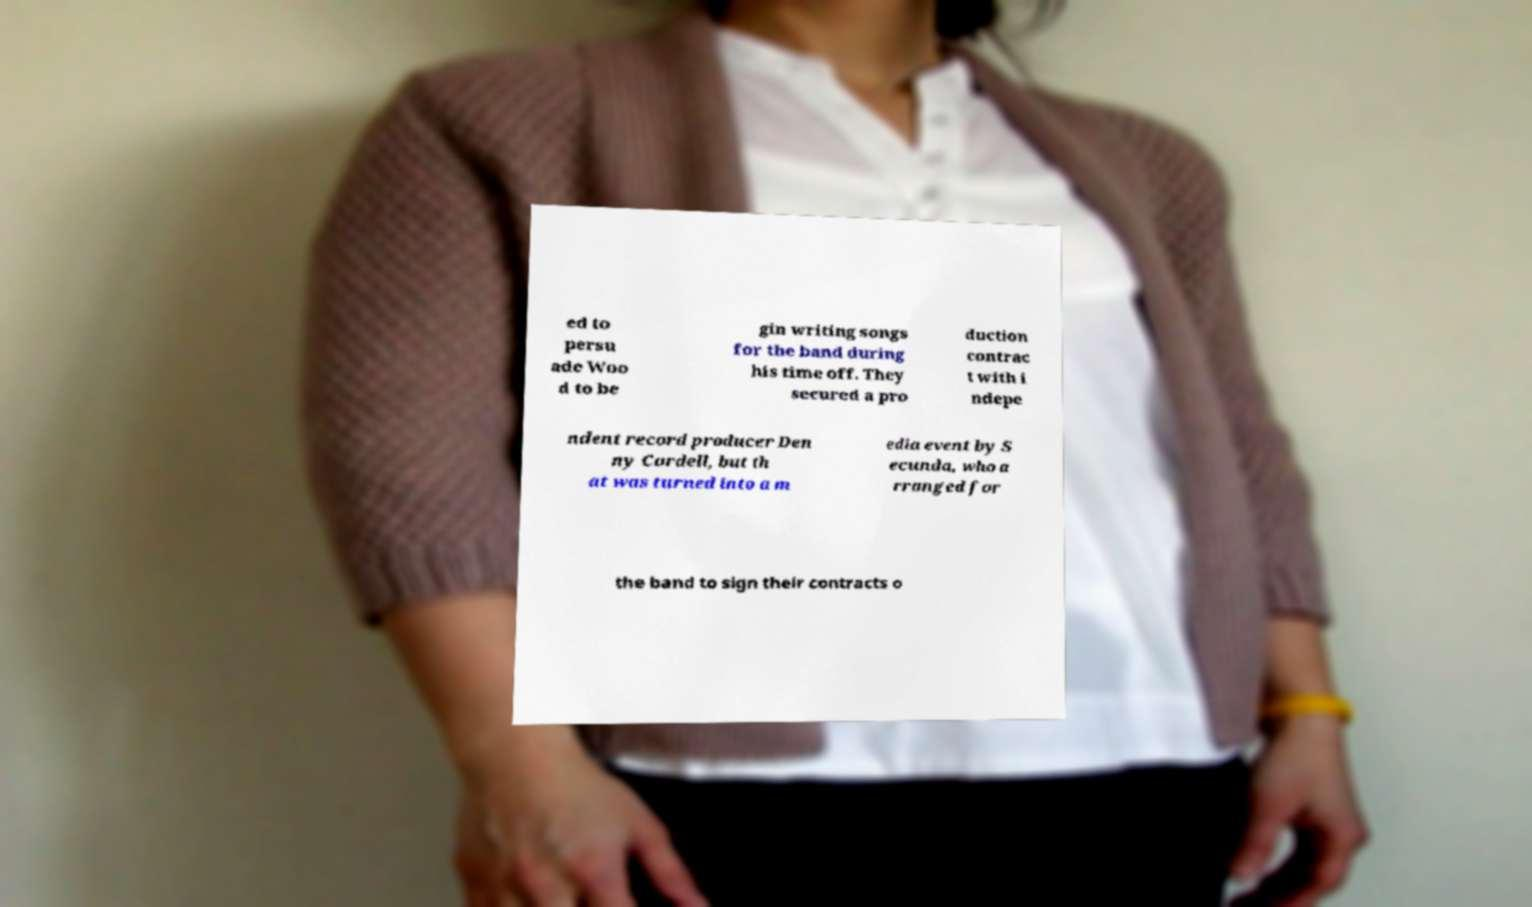Could you extract and type out the text from this image? ed to persu ade Woo d to be gin writing songs for the band during his time off. They secured a pro duction contrac t with i ndepe ndent record producer Den ny Cordell, but th at was turned into a m edia event by S ecunda, who a rranged for the band to sign their contracts o 